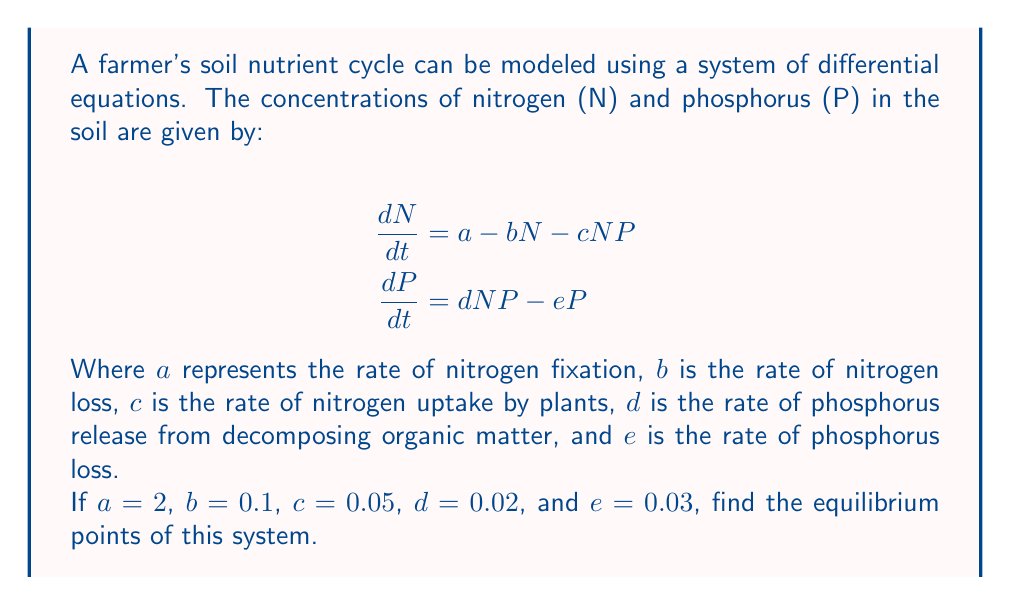Help me with this question. To find the equilibrium points, we need to set both equations equal to zero and solve for N and P:

1) Set $\frac{dN}{dt} = 0$ and $\frac{dP}{dt} = 0$:

   $$0 = 2 - 0.1N - 0.05NP$$
   $$0 = 0.02NP - 0.03P$$

2) From the second equation:
   
   $$0.02NP - 0.03P = 0$$
   $$P(0.02N - 0.03) = 0$$

   This gives us two possibilities: $P = 0$ or $N = 1.5$

3) Case 1: If $P = 0$, substitute this into the first equation:

   $$0 = 2 - 0.1N - 0.05N(0)$$
   $$0 = 2 - 0.1N$$
   $$N = 20$$

   So one equilibrium point is $(20, 0)$

4) Case 2: If $N = 1.5$, substitute this into the first equation:

   $$0 = 2 - 0.1(1.5) - 0.05(1.5)P$$
   $$0 = 2 - 0.15 - 0.075P$$
   $$0.075P = 1.85$$
   $$P = 24.67$$

   So the other equilibrium point is $(1.5, 24.67)$

Therefore, the system has two equilibrium points: $(20, 0)$ and $(1.5, 24.67)$.
Answer: $(20, 0)$ and $(1.5, 24.67)$ 